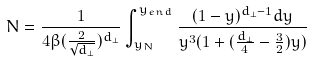<formula> <loc_0><loc_0><loc_500><loc_500>N = \frac { 1 } { 4 \beta ( \frac { 2 } { \sqrt { d _ { \perp } } } ) ^ { d _ { \perp } } } \int _ { y _ { N } } ^ { y _ { e n d } } \frac { ( 1 - y ) ^ { d _ { \perp } - 1 } d y } { y ^ { 3 } ( 1 + ( \frac { d _ { \perp } } { 4 } - \frac { 3 } { 2 } ) y ) }</formula> 